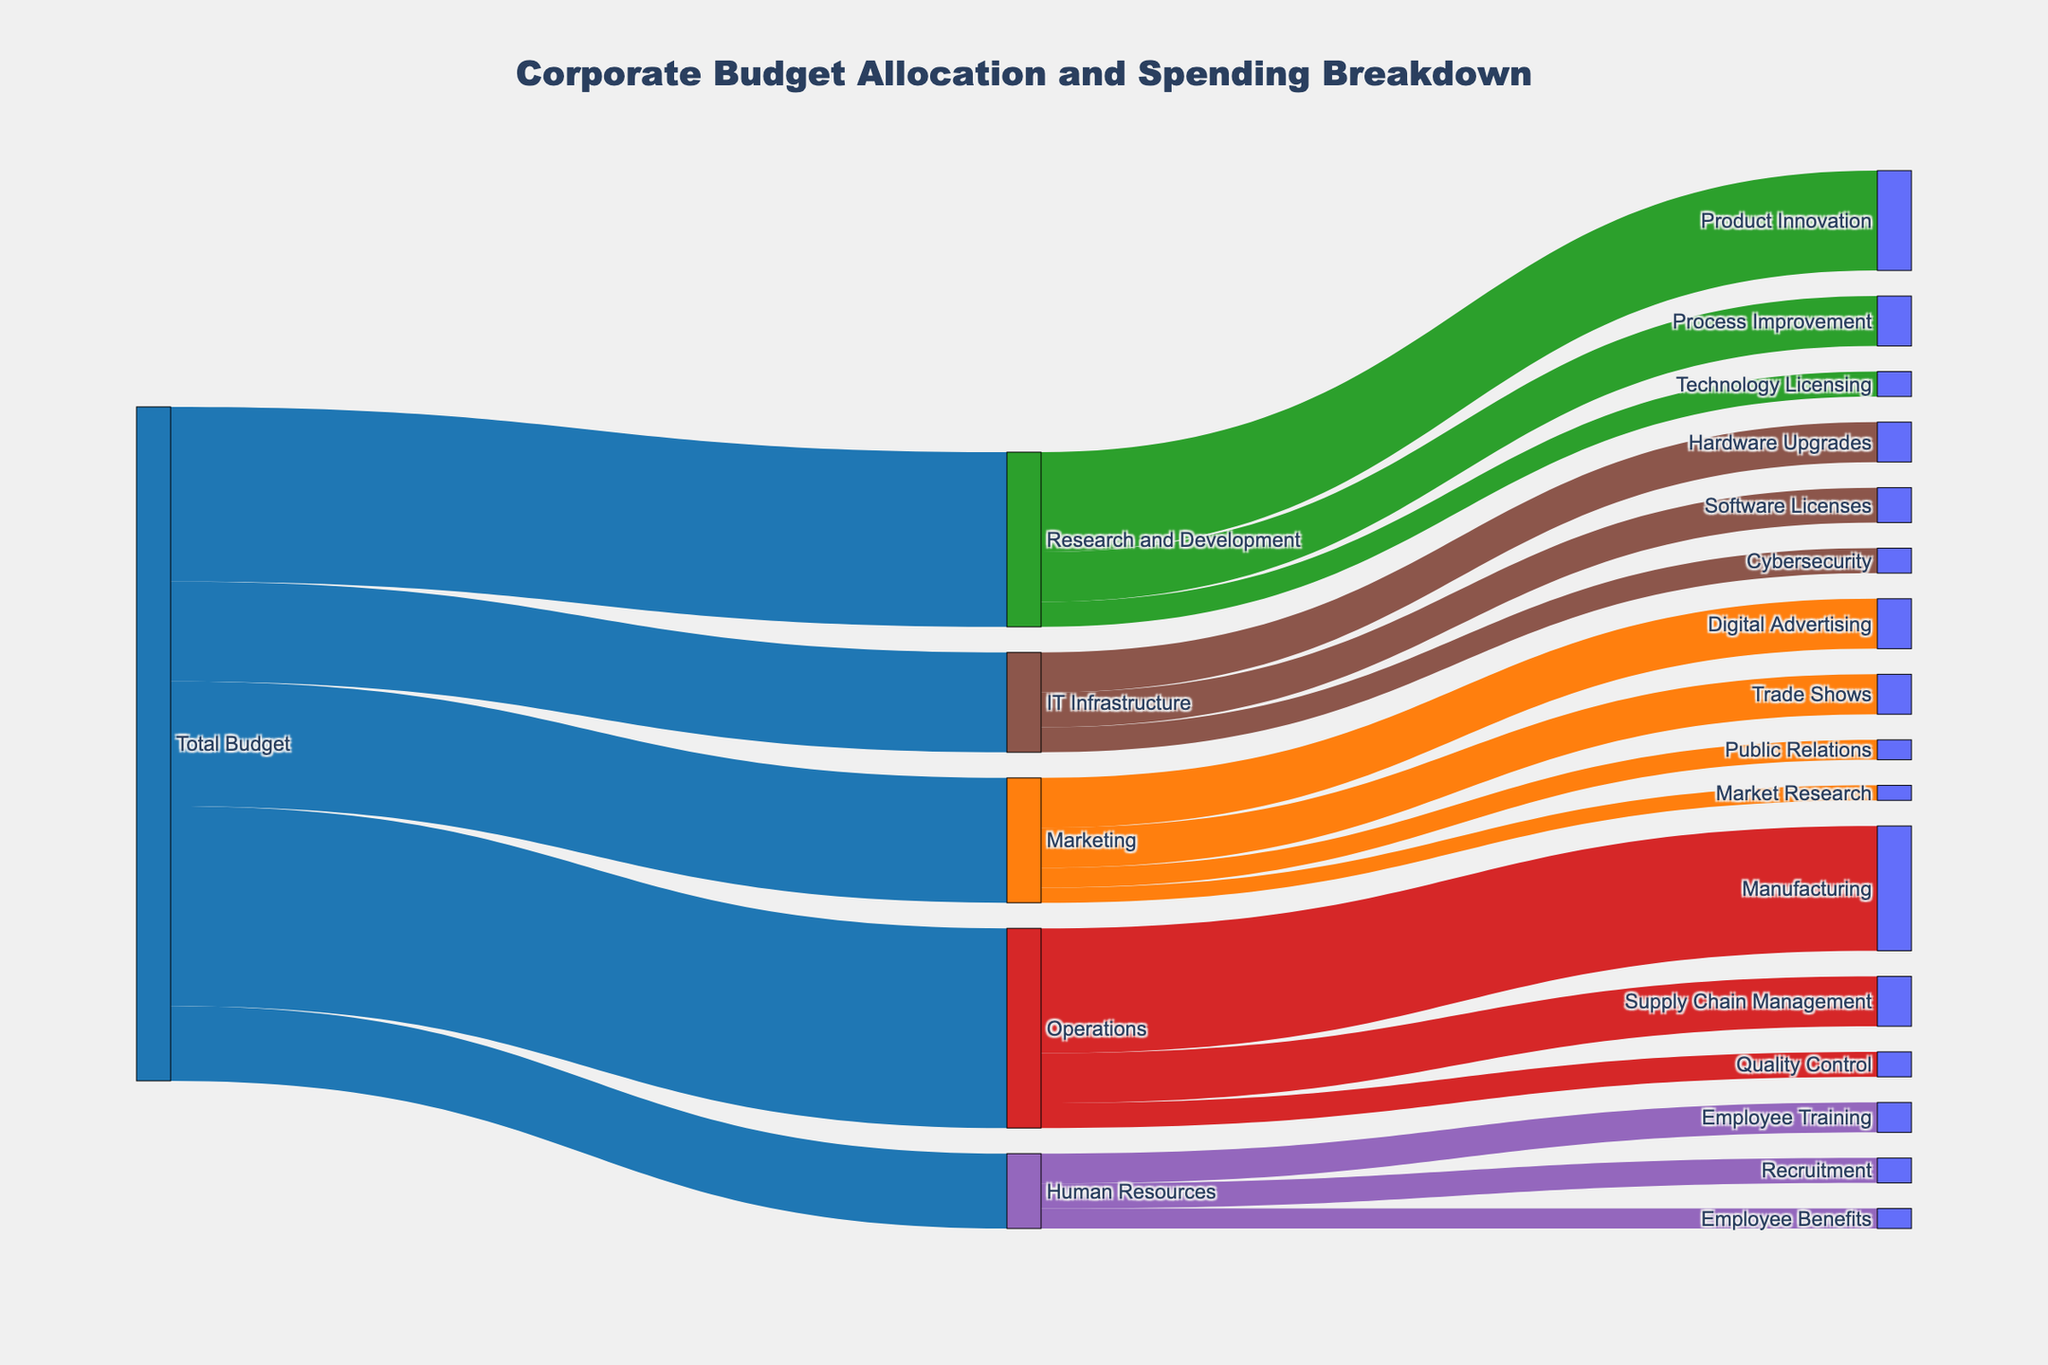What is the total budget for Marketing? The total budget for Marketing can be found at the link where 'Total Budget' flows to 'Marketing'. The value is labeled as 2,500,000.
Answer: 2,500,000 What is the largest allocation in the 'Marketing' category? In the 'Marketing' category, the largest value is the flow to 'Digital Advertising', which is labeled as 1,000,000.
Answer: Digital Advertising How much was allocated for Research and Development (R&D)? The total allocation for R&D can be found by looking at the link from 'Total Budget' to 'Research and Development', which is labeled as 3,500,000.
Answer: 3,500,000 Compare the budget allocated to Human Resources (HR) and IT Infrastructure. Which is higher and by how much? The budget allocated to HR is 1,500,000 and to IT Infrastructure is 2,000,000. The difference is 2,000,000 - 1,500,000 = 500,000, with IT Infrastructure being higher.
Answer: IT Infrastructure is higher by 500,000 What is the smallest allocation within the 'Human Resources' category? The 'Human Resources' category has values of 600,000 for Employee Training, 500,000 for Recruitment, and 400,000 for Employee Benefits. The smallest value is for Employee Benefits.
Answer: Employee Benefits What is the total budget for Operations? The value flows from 'Total Budget' to 'Operations', which is shown as 4,000,000.
Answer: 4,000,000 How does the budget for Digital Advertising compare to the budget for Employee Training? The budget for Digital Advertising is 1,000,000, while the budget for Employee Training is 600,000. Therefore, the budget for Digital Advertising is higher by 1,000,000 - 600,000 = 400,000.
Answer: Digital Advertising is 400,000 higher Sum the total allocation for IT Infrastructure. The IT Infrastructure category includes 800,000 for Hardware Upgrades, 700,000 for Software Licenses, and 500,000 for Cybersecurity. The sum is 800,000 + 700,000 + 500,000 = 2,000,000.
Answer: 2,000,000 Among 'Product Innovation', 'Process Improvement', and 'Technology Licensing', which has the smallest budget? In the Research and Development category, 'Product Innovation' has a budget of 2,000,000, 'Process Improvement' has 1,000,000, and 'Technology Licensing' has 500,000. The smallest budget is for Technology Licensing.
Answer: Technology Licensing Calculate the aggregate amount allocated to 'Marketing' and 'Research and Development'. The total budget for Marketing is 2,500,000 and for Research and Development is 3,500,000. The aggregate amount is 2,500,000 + 3,500,000 = 6,000,000.
Answer: 6,000,000 